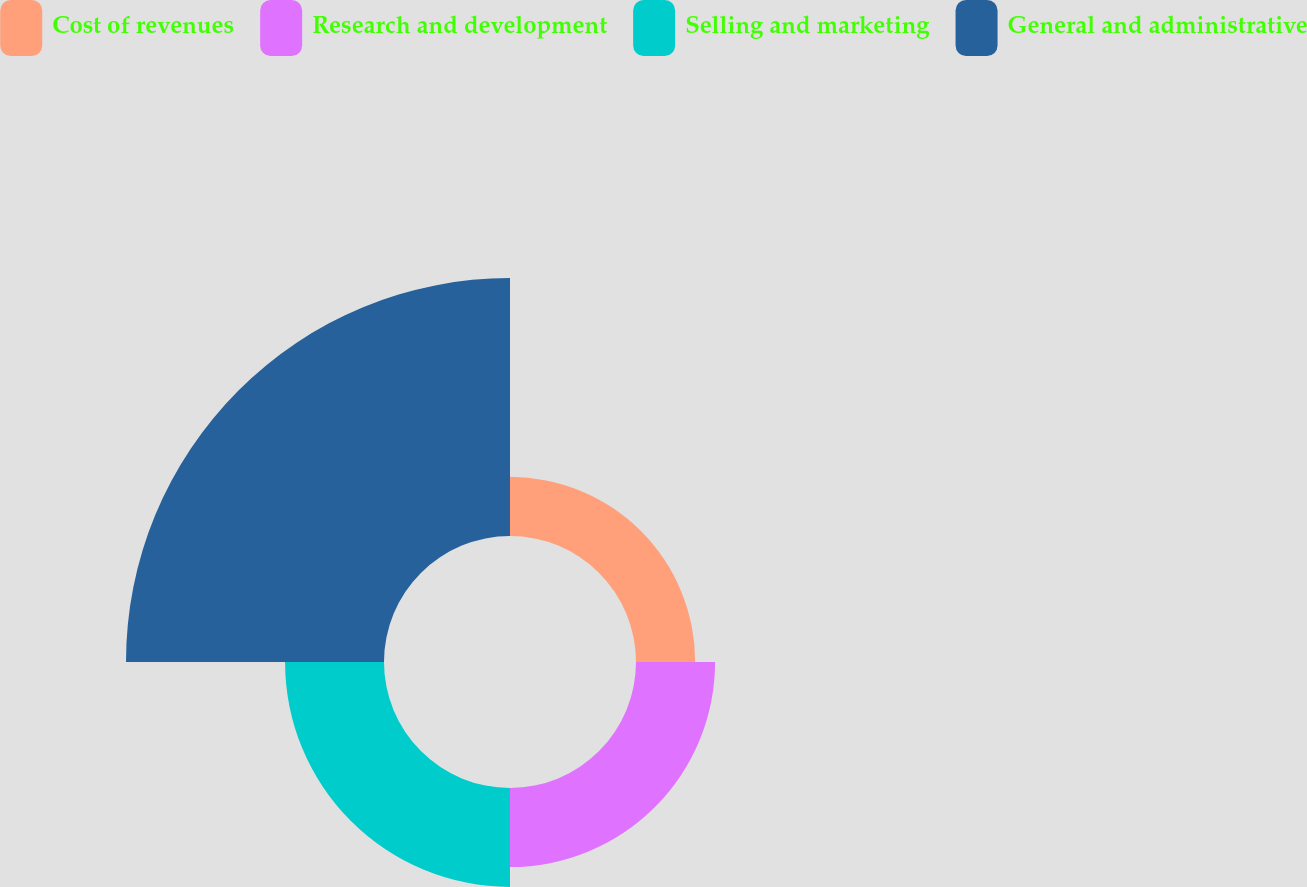Convert chart to OTSL. <chart><loc_0><loc_0><loc_500><loc_500><pie_chart><fcel>Cost of revenues<fcel>Research and development<fcel>Selling and marketing<fcel>General and administrative<nl><fcel>11.95%<fcel>15.97%<fcel>19.98%<fcel>52.1%<nl></chart> 